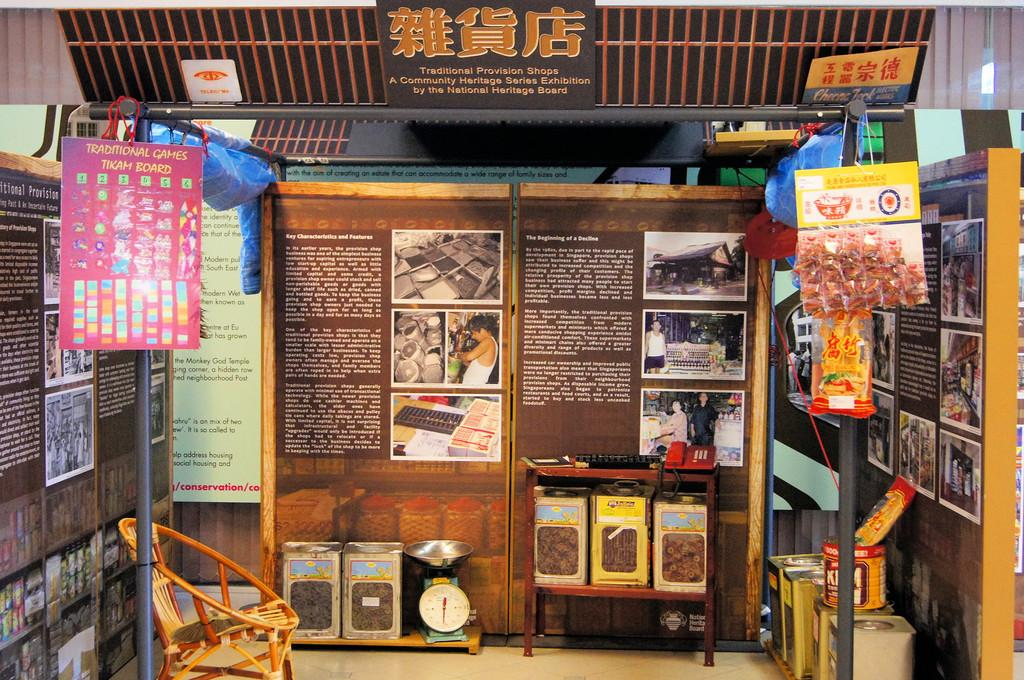<image>
Share a concise interpretation of the image provided. A traditional games tikam board is shown in a space filled with cultural posters and pictures. 